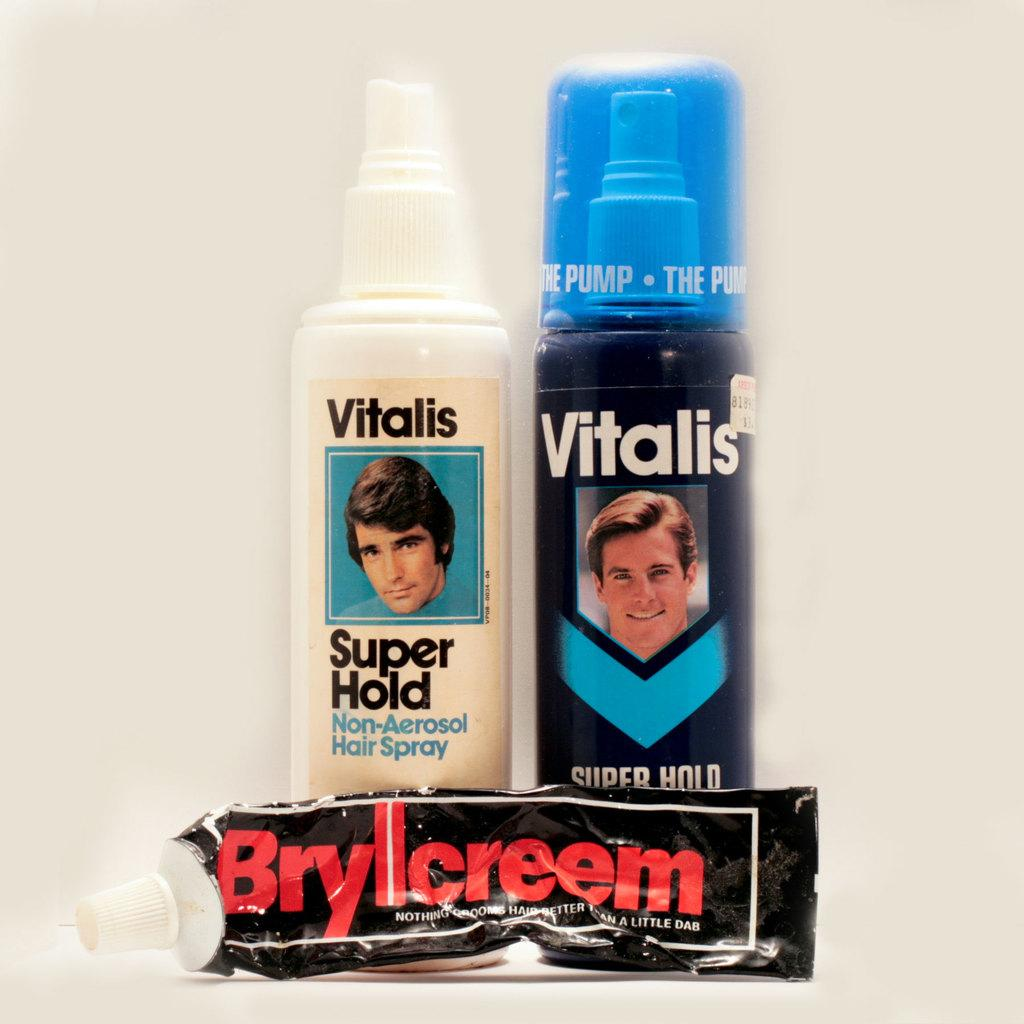<image>
Describe the image concisely. two bottles of vitalis hair cream and a tube of brylcream 